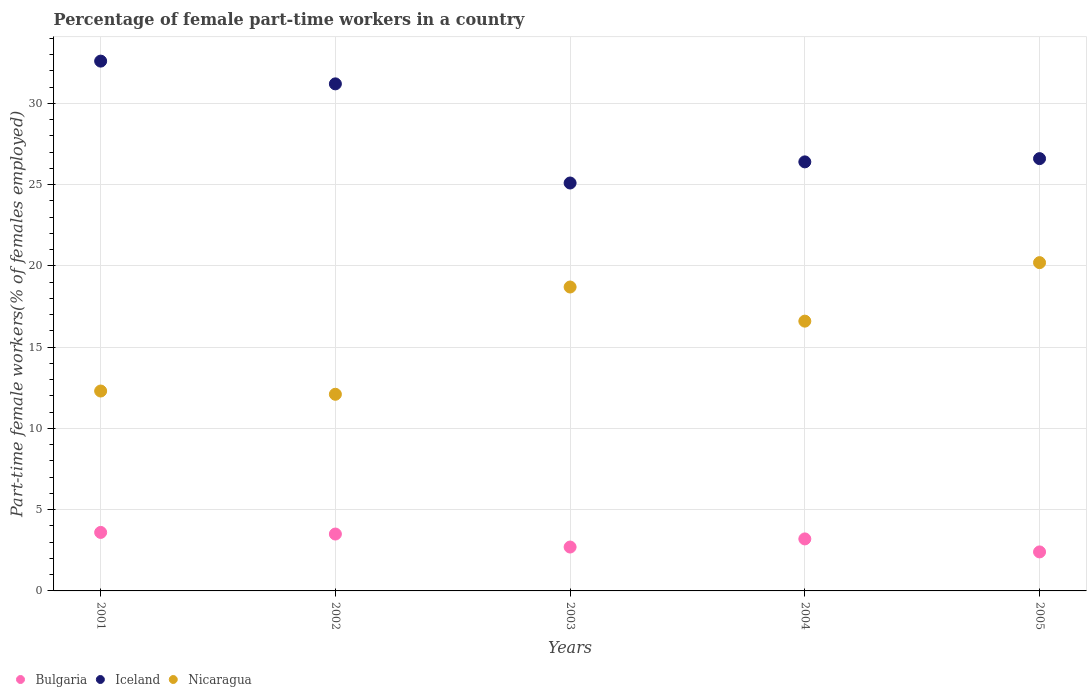How many different coloured dotlines are there?
Offer a terse response. 3. What is the percentage of female part-time workers in Nicaragua in 2002?
Your answer should be compact. 12.1. Across all years, what is the maximum percentage of female part-time workers in Iceland?
Give a very brief answer. 32.6. Across all years, what is the minimum percentage of female part-time workers in Bulgaria?
Offer a terse response. 2.4. What is the total percentage of female part-time workers in Bulgaria in the graph?
Your answer should be compact. 15.4. What is the difference between the percentage of female part-time workers in Iceland in 2002 and that in 2005?
Keep it short and to the point. 4.6. What is the difference between the percentage of female part-time workers in Bulgaria in 2004 and the percentage of female part-time workers in Iceland in 2001?
Keep it short and to the point. -29.4. What is the average percentage of female part-time workers in Nicaragua per year?
Offer a very short reply. 15.98. In the year 2002, what is the difference between the percentage of female part-time workers in Nicaragua and percentage of female part-time workers in Iceland?
Ensure brevity in your answer.  -19.1. What is the ratio of the percentage of female part-time workers in Nicaragua in 2002 to that in 2005?
Your answer should be very brief. 0.6. Is the percentage of female part-time workers in Iceland in 2004 less than that in 2005?
Your answer should be compact. Yes. Is the difference between the percentage of female part-time workers in Nicaragua in 2001 and 2004 greater than the difference between the percentage of female part-time workers in Iceland in 2001 and 2004?
Your response must be concise. No. What is the difference between the highest and the second highest percentage of female part-time workers in Iceland?
Your answer should be compact. 1.4. What is the difference between the highest and the lowest percentage of female part-time workers in Nicaragua?
Your answer should be very brief. 8.1. Is it the case that in every year, the sum of the percentage of female part-time workers in Iceland and percentage of female part-time workers in Bulgaria  is greater than the percentage of female part-time workers in Nicaragua?
Offer a very short reply. Yes. Is the percentage of female part-time workers in Bulgaria strictly greater than the percentage of female part-time workers in Iceland over the years?
Provide a succinct answer. No. Are the values on the major ticks of Y-axis written in scientific E-notation?
Offer a terse response. No. How many legend labels are there?
Your answer should be compact. 3. How are the legend labels stacked?
Make the answer very short. Horizontal. What is the title of the graph?
Make the answer very short. Percentage of female part-time workers in a country. Does "Denmark" appear as one of the legend labels in the graph?
Give a very brief answer. No. What is the label or title of the Y-axis?
Your response must be concise. Part-time female workers(% of females employed). What is the Part-time female workers(% of females employed) of Bulgaria in 2001?
Ensure brevity in your answer.  3.6. What is the Part-time female workers(% of females employed) in Iceland in 2001?
Provide a short and direct response. 32.6. What is the Part-time female workers(% of females employed) in Nicaragua in 2001?
Offer a very short reply. 12.3. What is the Part-time female workers(% of females employed) in Bulgaria in 2002?
Your answer should be very brief. 3.5. What is the Part-time female workers(% of females employed) of Iceland in 2002?
Offer a terse response. 31.2. What is the Part-time female workers(% of females employed) in Nicaragua in 2002?
Ensure brevity in your answer.  12.1. What is the Part-time female workers(% of females employed) in Bulgaria in 2003?
Your response must be concise. 2.7. What is the Part-time female workers(% of females employed) of Iceland in 2003?
Make the answer very short. 25.1. What is the Part-time female workers(% of females employed) of Nicaragua in 2003?
Your answer should be compact. 18.7. What is the Part-time female workers(% of females employed) of Bulgaria in 2004?
Offer a very short reply. 3.2. What is the Part-time female workers(% of females employed) of Iceland in 2004?
Provide a succinct answer. 26.4. What is the Part-time female workers(% of females employed) in Nicaragua in 2004?
Give a very brief answer. 16.6. What is the Part-time female workers(% of females employed) in Bulgaria in 2005?
Your response must be concise. 2.4. What is the Part-time female workers(% of females employed) of Iceland in 2005?
Give a very brief answer. 26.6. What is the Part-time female workers(% of females employed) in Nicaragua in 2005?
Ensure brevity in your answer.  20.2. Across all years, what is the maximum Part-time female workers(% of females employed) in Bulgaria?
Your answer should be compact. 3.6. Across all years, what is the maximum Part-time female workers(% of females employed) in Iceland?
Offer a terse response. 32.6. Across all years, what is the maximum Part-time female workers(% of females employed) of Nicaragua?
Keep it short and to the point. 20.2. Across all years, what is the minimum Part-time female workers(% of females employed) of Bulgaria?
Your response must be concise. 2.4. Across all years, what is the minimum Part-time female workers(% of females employed) of Iceland?
Your answer should be very brief. 25.1. Across all years, what is the minimum Part-time female workers(% of females employed) of Nicaragua?
Your answer should be very brief. 12.1. What is the total Part-time female workers(% of females employed) of Bulgaria in the graph?
Ensure brevity in your answer.  15.4. What is the total Part-time female workers(% of females employed) of Iceland in the graph?
Offer a terse response. 141.9. What is the total Part-time female workers(% of females employed) in Nicaragua in the graph?
Your response must be concise. 79.9. What is the difference between the Part-time female workers(% of females employed) in Bulgaria in 2001 and that in 2002?
Ensure brevity in your answer.  0.1. What is the difference between the Part-time female workers(% of females employed) of Iceland in 2001 and that in 2002?
Your answer should be very brief. 1.4. What is the difference between the Part-time female workers(% of females employed) of Nicaragua in 2001 and that in 2003?
Give a very brief answer. -6.4. What is the difference between the Part-time female workers(% of females employed) in Iceland in 2001 and that in 2004?
Provide a succinct answer. 6.2. What is the difference between the Part-time female workers(% of females employed) of Iceland in 2001 and that in 2005?
Your answer should be very brief. 6. What is the difference between the Part-time female workers(% of females employed) in Nicaragua in 2001 and that in 2005?
Give a very brief answer. -7.9. What is the difference between the Part-time female workers(% of females employed) in Iceland in 2002 and that in 2003?
Provide a succinct answer. 6.1. What is the difference between the Part-time female workers(% of females employed) in Iceland in 2002 and that in 2004?
Make the answer very short. 4.8. What is the difference between the Part-time female workers(% of females employed) in Nicaragua in 2002 and that in 2004?
Provide a succinct answer. -4.5. What is the difference between the Part-time female workers(% of females employed) of Bulgaria in 2002 and that in 2005?
Make the answer very short. 1.1. What is the difference between the Part-time female workers(% of females employed) of Nicaragua in 2002 and that in 2005?
Keep it short and to the point. -8.1. What is the difference between the Part-time female workers(% of females employed) in Iceland in 2004 and that in 2005?
Keep it short and to the point. -0.2. What is the difference between the Part-time female workers(% of females employed) in Bulgaria in 2001 and the Part-time female workers(% of females employed) in Iceland in 2002?
Your answer should be compact. -27.6. What is the difference between the Part-time female workers(% of females employed) of Bulgaria in 2001 and the Part-time female workers(% of females employed) of Iceland in 2003?
Ensure brevity in your answer.  -21.5. What is the difference between the Part-time female workers(% of females employed) in Bulgaria in 2001 and the Part-time female workers(% of females employed) in Nicaragua in 2003?
Offer a terse response. -15.1. What is the difference between the Part-time female workers(% of females employed) of Iceland in 2001 and the Part-time female workers(% of females employed) of Nicaragua in 2003?
Provide a succinct answer. 13.9. What is the difference between the Part-time female workers(% of females employed) of Bulgaria in 2001 and the Part-time female workers(% of females employed) of Iceland in 2004?
Offer a terse response. -22.8. What is the difference between the Part-time female workers(% of females employed) of Bulgaria in 2001 and the Part-time female workers(% of females employed) of Nicaragua in 2004?
Your response must be concise. -13. What is the difference between the Part-time female workers(% of females employed) in Bulgaria in 2001 and the Part-time female workers(% of females employed) in Nicaragua in 2005?
Make the answer very short. -16.6. What is the difference between the Part-time female workers(% of females employed) in Iceland in 2001 and the Part-time female workers(% of females employed) in Nicaragua in 2005?
Offer a terse response. 12.4. What is the difference between the Part-time female workers(% of females employed) of Bulgaria in 2002 and the Part-time female workers(% of females employed) of Iceland in 2003?
Your answer should be compact. -21.6. What is the difference between the Part-time female workers(% of females employed) in Bulgaria in 2002 and the Part-time female workers(% of females employed) in Nicaragua in 2003?
Provide a short and direct response. -15.2. What is the difference between the Part-time female workers(% of females employed) in Bulgaria in 2002 and the Part-time female workers(% of females employed) in Iceland in 2004?
Make the answer very short. -22.9. What is the difference between the Part-time female workers(% of females employed) in Bulgaria in 2002 and the Part-time female workers(% of females employed) in Iceland in 2005?
Provide a succinct answer. -23.1. What is the difference between the Part-time female workers(% of females employed) of Bulgaria in 2002 and the Part-time female workers(% of females employed) of Nicaragua in 2005?
Provide a succinct answer. -16.7. What is the difference between the Part-time female workers(% of females employed) in Bulgaria in 2003 and the Part-time female workers(% of females employed) in Iceland in 2004?
Keep it short and to the point. -23.7. What is the difference between the Part-time female workers(% of females employed) of Iceland in 2003 and the Part-time female workers(% of females employed) of Nicaragua in 2004?
Ensure brevity in your answer.  8.5. What is the difference between the Part-time female workers(% of females employed) of Bulgaria in 2003 and the Part-time female workers(% of females employed) of Iceland in 2005?
Give a very brief answer. -23.9. What is the difference between the Part-time female workers(% of females employed) in Bulgaria in 2003 and the Part-time female workers(% of females employed) in Nicaragua in 2005?
Make the answer very short. -17.5. What is the difference between the Part-time female workers(% of females employed) of Iceland in 2003 and the Part-time female workers(% of females employed) of Nicaragua in 2005?
Provide a succinct answer. 4.9. What is the difference between the Part-time female workers(% of females employed) of Bulgaria in 2004 and the Part-time female workers(% of females employed) of Iceland in 2005?
Offer a very short reply. -23.4. What is the difference between the Part-time female workers(% of females employed) in Bulgaria in 2004 and the Part-time female workers(% of females employed) in Nicaragua in 2005?
Provide a succinct answer. -17. What is the average Part-time female workers(% of females employed) in Bulgaria per year?
Your response must be concise. 3.08. What is the average Part-time female workers(% of females employed) in Iceland per year?
Offer a very short reply. 28.38. What is the average Part-time female workers(% of females employed) in Nicaragua per year?
Provide a short and direct response. 15.98. In the year 2001, what is the difference between the Part-time female workers(% of females employed) of Iceland and Part-time female workers(% of females employed) of Nicaragua?
Your response must be concise. 20.3. In the year 2002, what is the difference between the Part-time female workers(% of females employed) of Bulgaria and Part-time female workers(% of females employed) of Iceland?
Your response must be concise. -27.7. In the year 2002, what is the difference between the Part-time female workers(% of females employed) in Bulgaria and Part-time female workers(% of females employed) in Nicaragua?
Provide a succinct answer. -8.6. In the year 2003, what is the difference between the Part-time female workers(% of females employed) of Bulgaria and Part-time female workers(% of females employed) of Iceland?
Your answer should be compact. -22.4. In the year 2003, what is the difference between the Part-time female workers(% of females employed) of Iceland and Part-time female workers(% of females employed) of Nicaragua?
Keep it short and to the point. 6.4. In the year 2004, what is the difference between the Part-time female workers(% of females employed) in Bulgaria and Part-time female workers(% of females employed) in Iceland?
Offer a terse response. -23.2. In the year 2004, what is the difference between the Part-time female workers(% of females employed) in Bulgaria and Part-time female workers(% of females employed) in Nicaragua?
Offer a very short reply. -13.4. In the year 2004, what is the difference between the Part-time female workers(% of females employed) in Iceland and Part-time female workers(% of females employed) in Nicaragua?
Your answer should be very brief. 9.8. In the year 2005, what is the difference between the Part-time female workers(% of females employed) of Bulgaria and Part-time female workers(% of females employed) of Iceland?
Your response must be concise. -24.2. In the year 2005, what is the difference between the Part-time female workers(% of females employed) of Bulgaria and Part-time female workers(% of females employed) of Nicaragua?
Make the answer very short. -17.8. In the year 2005, what is the difference between the Part-time female workers(% of females employed) of Iceland and Part-time female workers(% of females employed) of Nicaragua?
Your answer should be compact. 6.4. What is the ratio of the Part-time female workers(% of females employed) in Bulgaria in 2001 to that in 2002?
Your answer should be compact. 1.03. What is the ratio of the Part-time female workers(% of females employed) of Iceland in 2001 to that in 2002?
Offer a terse response. 1.04. What is the ratio of the Part-time female workers(% of females employed) of Nicaragua in 2001 to that in 2002?
Your answer should be very brief. 1.02. What is the ratio of the Part-time female workers(% of females employed) of Iceland in 2001 to that in 2003?
Offer a terse response. 1.3. What is the ratio of the Part-time female workers(% of females employed) in Nicaragua in 2001 to that in 2003?
Give a very brief answer. 0.66. What is the ratio of the Part-time female workers(% of females employed) of Bulgaria in 2001 to that in 2004?
Provide a succinct answer. 1.12. What is the ratio of the Part-time female workers(% of females employed) of Iceland in 2001 to that in 2004?
Provide a succinct answer. 1.23. What is the ratio of the Part-time female workers(% of females employed) in Nicaragua in 2001 to that in 2004?
Ensure brevity in your answer.  0.74. What is the ratio of the Part-time female workers(% of females employed) of Iceland in 2001 to that in 2005?
Make the answer very short. 1.23. What is the ratio of the Part-time female workers(% of females employed) in Nicaragua in 2001 to that in 2005?
Make the answer very short. 0.61. What is the ratio of the Part-time female workers(% of females employed) in Bulgaria in 2002 to that in 2003?
Keep it short and to the point. 1.3. What is the ratio of the Part-time female workers(% of females employed) in Iceland in 2002 to that in 2003?
Keep it short and to the point. 1.24. What is the ratio of the Part-time female workers(% of females employed) in Nicaragua in 2002 to that in 2003?
Offer a very short reply. 0.65. What is the ratio of the Part-time female workers(% of females employed) in Bulgaria in 2002 to that in 2004?
Provide a succinct answer. 1.09. What is the ratio of the Part-time female workers(% of females employed) in Iceland in 2002 to that in 2004?
Your response must be concise. 1.18. What is the ratio of the Part-time female workers(% of females employed) of Nicaragua in 2002 to that in 2004?
Make the answer very short. 0.73. What is the ratio of the Part-time female workers(% of females employed) in Bulgaria in 2002 to that in 2005?
Provide a succinct answer. 1.46. What is the ratio of the Part-time female workers(% of females employed) of Iceland in 2002 to that in 2005?
Your answer should be compact. 1.17. What is the ratio of the Part-time female workers(% of females employed) of Nicaragua in 2002 to that in 2005?
Give a very brief answer. 0.6. What is the ratio of the Part-time female workers(% of females employed) in Bulgaria in 2003 to that in 2004?
Your answer should be very brief. 0.84. What is the ratio of the Part-time female workers(% of females employed) in Iceland in 2003 to that in 2004?
Your answer should be very brief. 0.95. What is the ratio of the Part-time female workers(% of females employed) of Nicaragua in 2003 to that in 2004?
Provide a short and direct response. 1.13. What is the ratio of the Part-time female workers(% of females employed) in Iceland in 2003 to that in 2005?
Your answer should be compact. 0.94. What is the ratio of the Part-time female workers(% of females employed) of Nicaragua in 2003 to that in 2005?
Give a very brief answer. 0.93. What is the ratio of the Part-time female workers(% of females employed) of Bulgaria in 2004 to that in 2005?
Provide a short and direct response. 1.33. What is the ratio of the Part-time female workers(% of females employed) of Nicaragua in 2004 to that in 2005?
Keep it short and to the point. 0.82. What is the difference between the highest and the second highest Part-time female workers(% of females employed) in Bulgaria?
Offer a terse response. 0.1. 